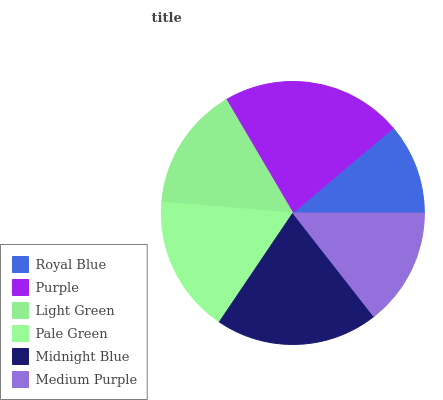Is Royal Blue the minimum?
Answer yes or no. Yes. Is Purple the maximum?
Answer yes or no. Yes. Is Light Green the minimum?
Answer yes or no. No. Is Light Green the maximum?
Answer yes or no. No. Is Purple greater than Light Green?
Answer yes or no. Yes. Is Light Green less than Purple?
Answer yes or no. Yes. Is Light Green greater than Purple?
Answer yes or no. No. Is Purple less than Light Green?
Answer yes or no. No. Is Pale Green the high median?
Answer yes or no. Yes. Is Light Green the low median?
Answer yes or no. Yes. Is Light Green the high median?
Answer yes or no. No. Is Midnight Blue the low median?
Answer yes or no. No. 